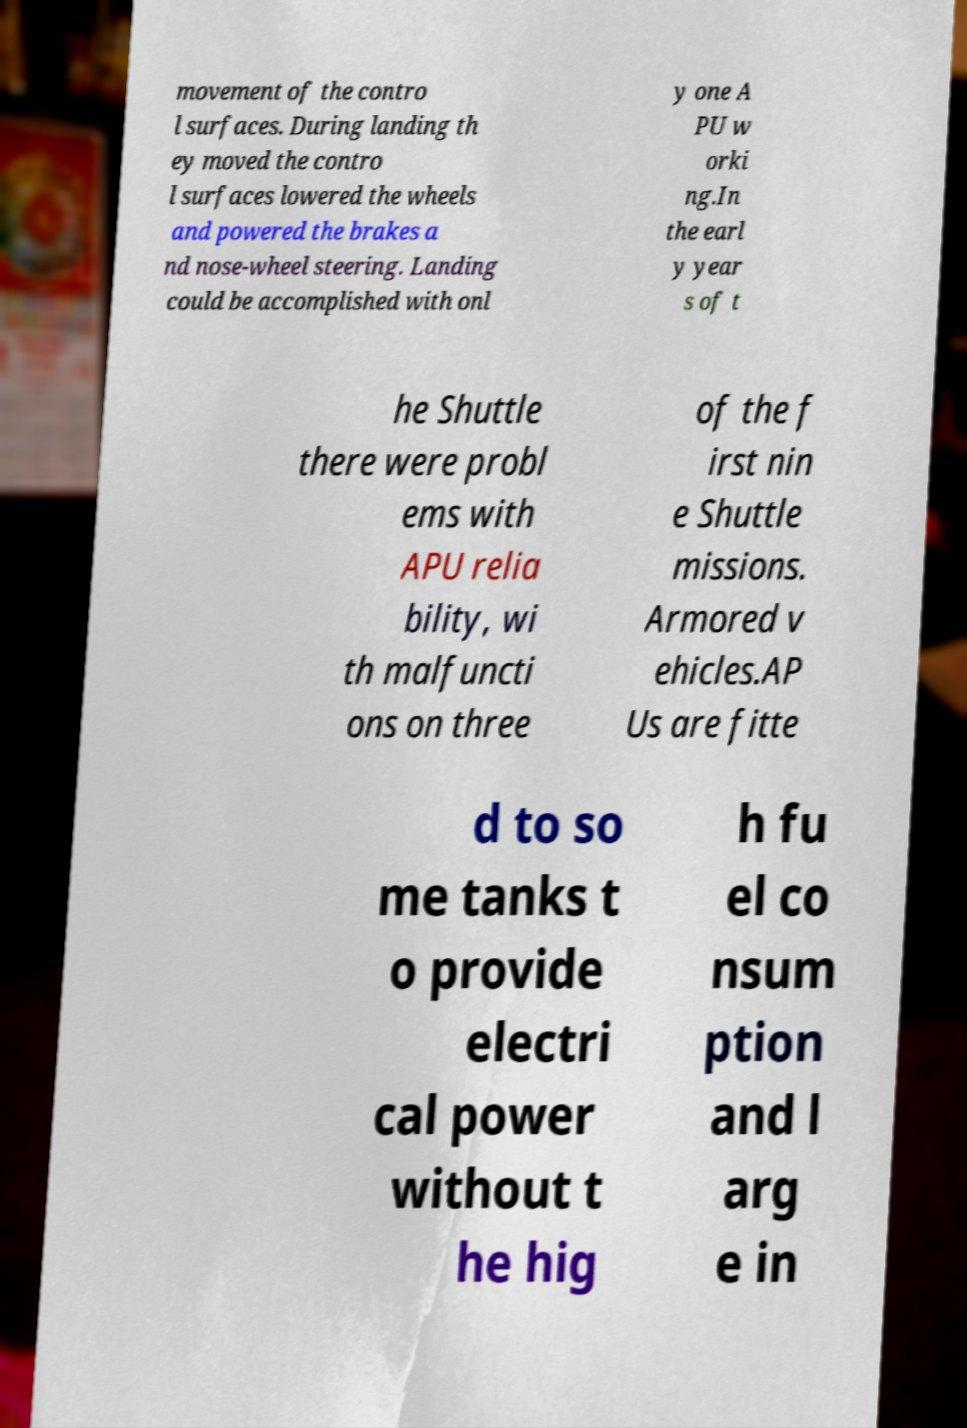There's text embedded in this image that I need extracted. Can you transcribe it verbatim? movement of the contro l surfaces. During landing th ey moved the contro l surfaces lowered the wheels and powered the brakes a nd nose-wheel steering. Landing could be accomplished with onl y one A PU w orki ng.In the earl y year s of t he Shuttle there were probl ems with APU relia bility, wi th malfuncti ons on three of the f irst nin e Shuttle missions. Armored v ehicles.AP Us are fitte d to so me tanks t o provide electri cal power without t he hig h fu el co nsum ption and l arg e in 